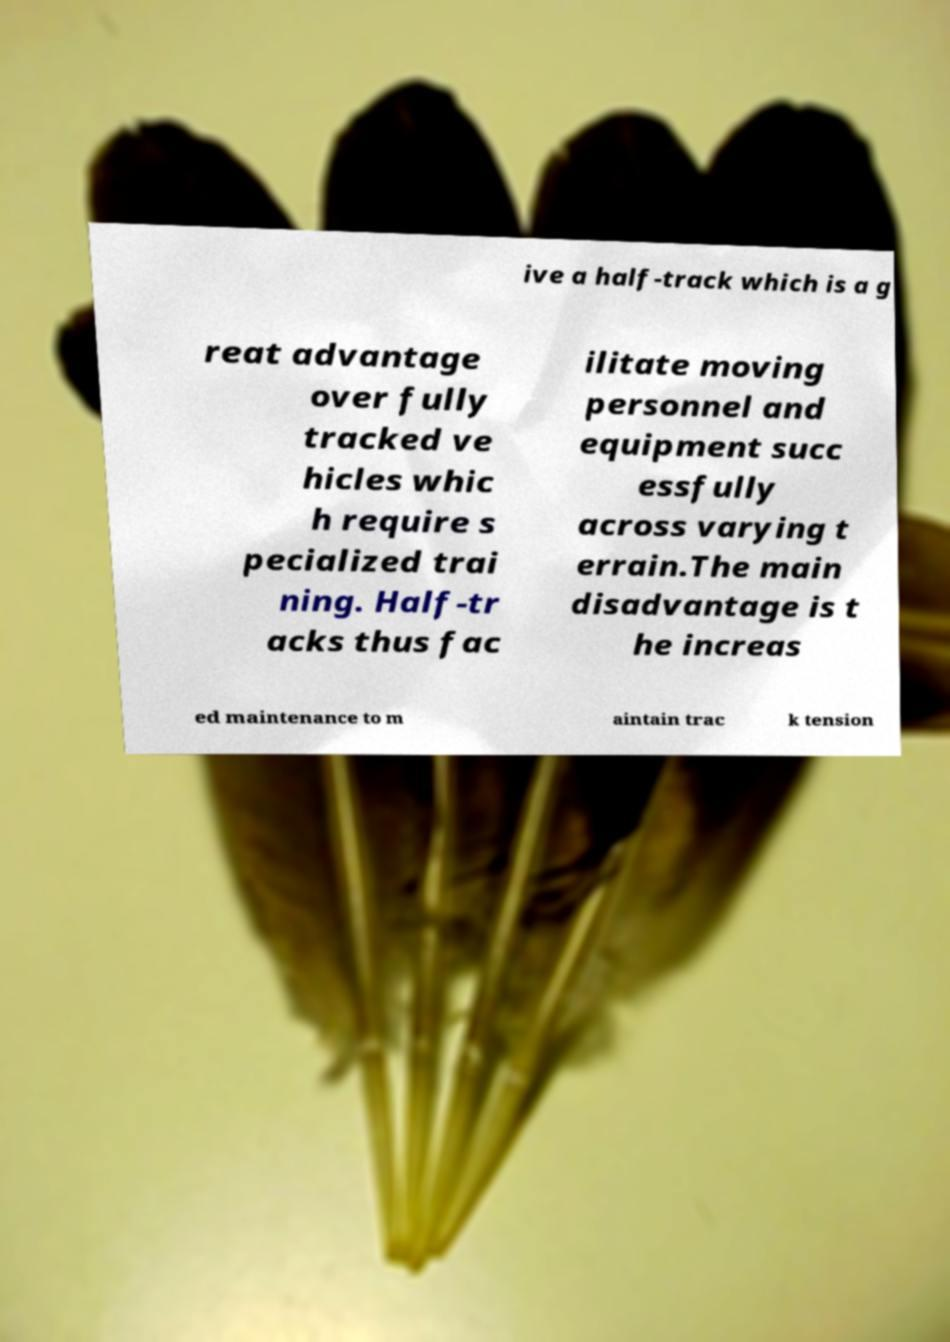Please identify and transcribe the text found in this image. ive a half-track which is a g reat advantage over fully tracked ve hicles whic h require s pecialized trai ning. Half-tr acks thus fac ilitate moving personnel and equipment succ essfully across varying t errain.The main disadvantage is t he increas ed maintenance to m aintain trac k tension 